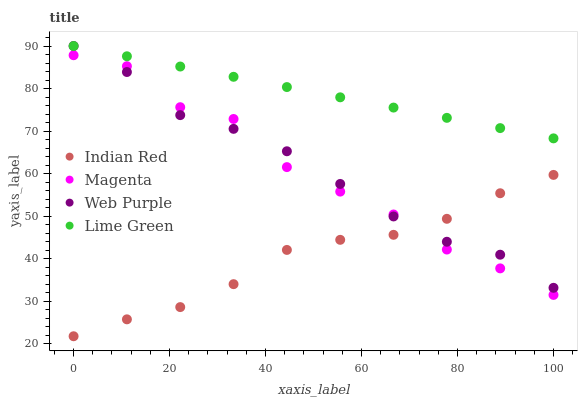Does Indian Red have the minimum area under the curve?
Answer yes or no. Yes. Does Lime Green have the maximum area under the curve?
Answer yes or no. Yes. Does Web Purple have the minimum area under the curve?
Answer yes or no. No. Does Web Purple have the maximum area under the curve?
Answer yes or no. No. Is Lime Green the smoothest?
Answer yes or no. Yes. Is Magenta the roughest?
Answer yes or no. Yes. Is Web Purple the smoothest?
Answer yes or no. No. Is Web Purple the roughest?
Answer yes or no. No. Does Indian Red have the lowest value?
Answer yes or no. Yes. Does Web Purple have the lowest value?
Answer yes or no. No. Does Web Purple have the highest value?
Answer yes or no. Yes. Does Indian Red have the highest value?
Answer yes or no. No. Is Indian Red less than Lime Green?
Answer yes or no. Yes. Is Lime Green greater than Indian Red?
Answer yes or no. Yes. Does Web Purple intersect Indian Red?
Answer yes or no. Yes. Is Web Purple less than Indian Red?
Answer yes or no. No. Is Web Purple greater than Indian Red?
Answer yes or no. No. Does Indian Red intersect Lime Green?
Answer yes or no. No. 